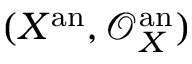<formula> <loc_0><loc_0><loc_500><loc_500>( X ^ { a n } , { \mathcal { O } } _ { X } ^ { a n } )</formula> 